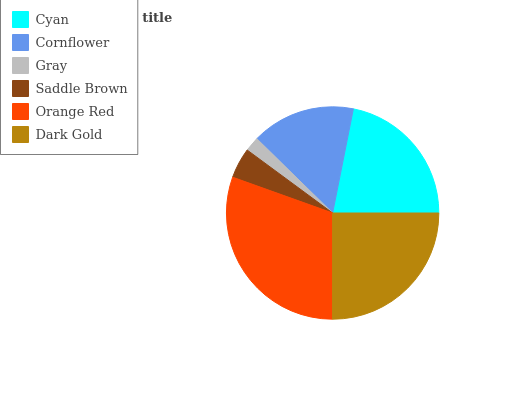Is Gray the minimum?
Answer yes or no. Yes. Is Orange Red the maximum?
Answer yes or no. Yes. Is Cornflower the minimum?
Answer yes or no. No. Is Cornflower the maximum?
Answer yes or no. No. Is Cyan greater than Cornflower?
Answer yes or no. Yes. Is Cornflower less than Cyan?
Answer yes or no. Yes. Is Cornflower greater than Cyan?
Answer yes or no. No. Is Cyan less than Cornflower?
Answer yes or no. No. Is Cyan the high median?
Answer yes or no. Yes. Is Cornflower the low median?
Answer yes or no. Yes. Is Saddle Brown the high median?
Answer yes or no. No. Is Dark Gold the low median?
Answer yes or no. No. 